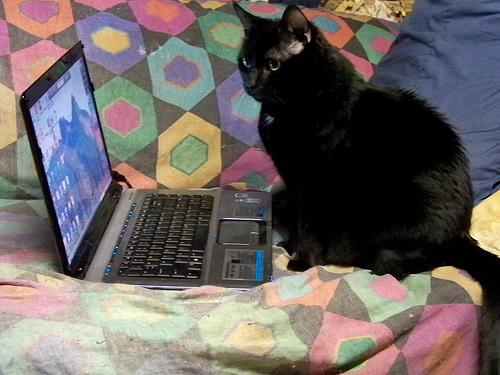Question: who is present?
Choices:
A. Men.
B. Women.
C. Children.
D. No one.
Answer with the letter. Answer: D Question: what is this?
Choices:
A. Cat.
B. Dog.
C. Frog.
D. Fish.
Answer with the letter. Answer: A Question: how is the cat?
Choices:
A. Standing.
B. Sleeping.
C. Lying down.
D. Seated.
Answer with the letter. Answer: D Question: what else is visible?
Choices:
A. Television.
B. Car.
C. Laptop.
D. Window.
Answer with the letter. Answer: C 